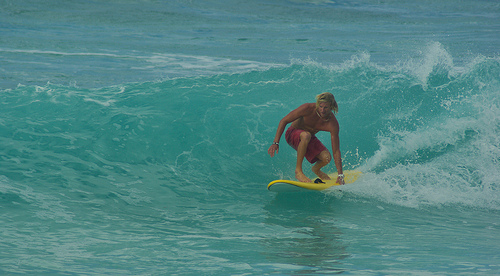Is the ocean calm or rough around the surfer? The ocean around the surfer appears moderately rough, with visible waves providing an ideal surfing environment. 